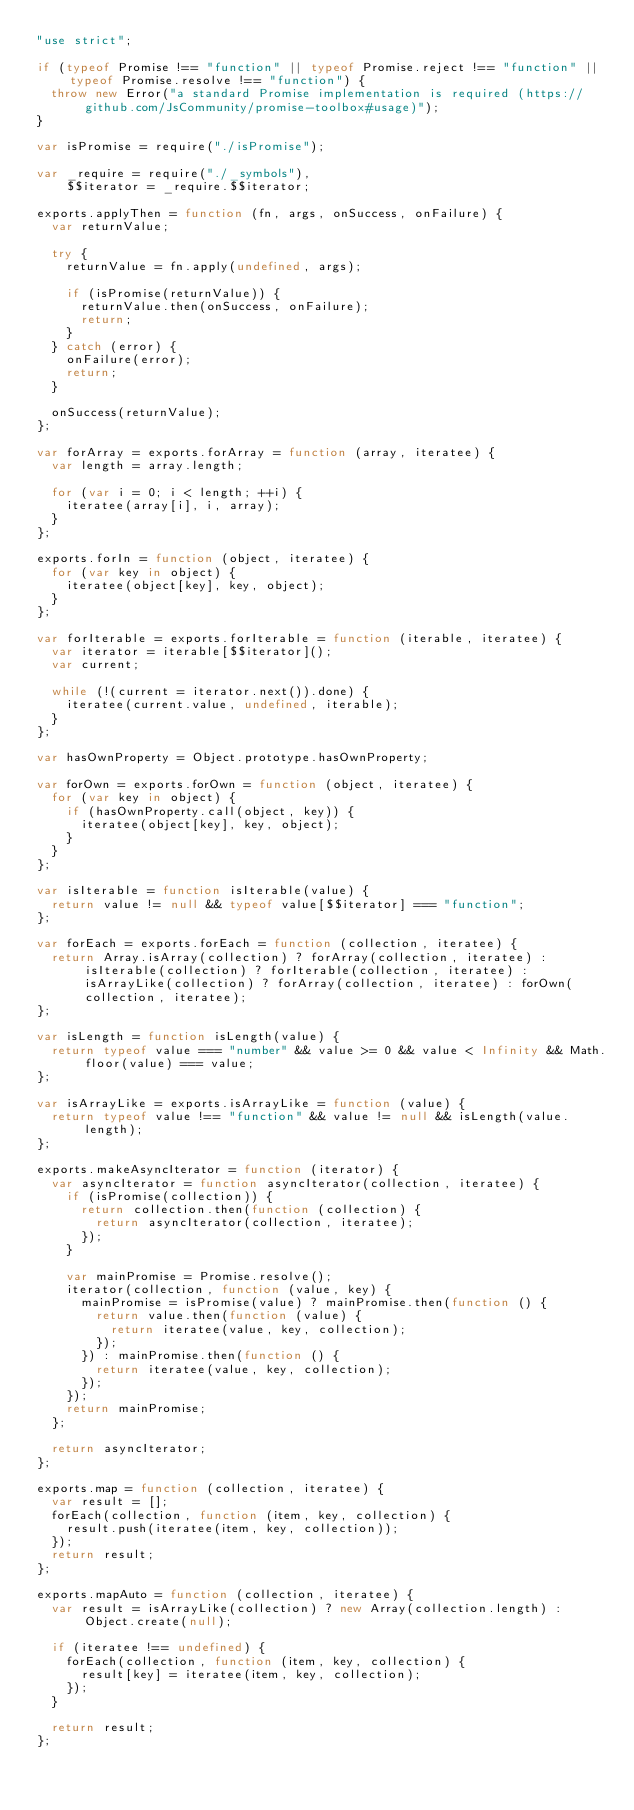Convert code to text. <code><loc_0><loc_0><loc_500><loc_500><_JavaScript_>"use strict";

if (typeof Promise !== "function" || typeof Promise.reject !== "function" || typeof Promise.resolve !== "function") {
  throw new Error("a standard Promise implementation is required (https://github.com/JsCommunity/promise-toolbox#usage)");
}

var isPromise = require("./isPromise");

var _require = require("./_symbols"),
    $$iterator = _require.$$iterator;

exports.applyThen = function (fn, args, onSuccess, onFailure) {
  var returnValue;

  try {
    returnValue = fn.apply(undefined, args);

    if (isPromise(returnValue)) {
      returnValue.then(onSuccess, onFailure);
      return;
    }
  } catch (error) {
    onFailure(error);
    return;
  }

  onSuccess(returnValue);
};

var forArray = exports.forArray = function (array, iteratee) {
  var length = array.length;

  for (var i = 0; i < length; ++i) {
    iteratee(array[i], i, array);
  }
};

exports.forIn = function (object, iteratee) {
  for (var key in object) {
    iteratee(object[key], key, object);
  }
};

var forIterable = exports.forIterable = function (iterable, iteratee) {
  var iterator = iterable[$$iterator]();
  var current;

  while (!(current = iterator.next()).done) {
    iteratee(current.value, undefined, iterable);
  }
};

var hasOwnProperty = Object.prototype.hasOwnProperty;

var forOwn = exports.forOwn = function (object, iteratee) {
  for (var key in object) {
    if (hasOwnProperty.call(object, key)) {
      iteratee(object[key], key, object);
    }
  }
};

var isIterable = function isIterable(value) {
  return value != null && typeof value[$$iterator] === "function";
};

var forEach = exports.forEach = function (collection, iteratee) {
  return Array.isArray(collection) ? forArray(collection, iteratee) : isIterable(collection) ? forIterable(collection, iteratee) : isArrayLike(collection) ? forArray(collection, iteratee) : forOwn(collection, iteratee);
};

var isLength = function isLength(value) {
  return typeof value === "number" && value >= 0 && value < Infinity && Math.floor(value) === value;
};

var isArrayLike = exports.isArrayLike = function (value) {
  return typeof value !== "function" && value != null && isLength(value.length);
};

exports.makeAsyncIterator = function (iterator) {
  var asyncIterator = function asyncIterator(collection, iteratee) {
    if (isPromise(collection)) {
      return collection.then(function (collection) {
        return asyncIterator(collection, iteratee);
      });
    }

    var mainPromise = Promise.resolve();
    iterator(collection, function (value, key) {
      mainPromise = isPromise(value) ? mainPromise.then(function () {
        return value.then(function (value) {
          return iteratee(value, key, collection);
        });
      }) : mainPromise.then(function () {
        return iteratee(value, key, collection);
      });
    });
    return mainPromise;
  };

  return asyncIterator;
};

exports.map = function (collection, iteratee) {
  var result = [];
  forEach(collection, function (item, key, collection) {
    result.push(iteratee(item, key, collection));
  });
  return result;
};

exports.mapAuto = function (collection, iteratee) {
  var result = isArrayLike(collection) ? new Array(collection.length) : Object.create(null);

  if (iteratee !== undefined) {
    forEach(collection, function (item, key, collection) {
      result[key] = iteratee(item, key, collection);
    });
  }

  return result;
};</code> 